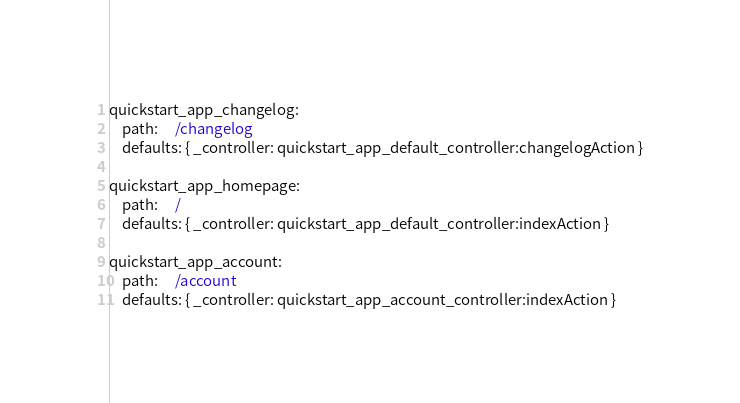<code> <loc_0><loc_0><loc_500><loc_500><_YAML_>quickstart_app_changelog:
    path:     /changelog
    defaults: { _controller: quickstart_app_default_controller:changelogAction }

quickstart_app_homepage:
    path:     /
    defaults: { _controller: quickstart_app_default_controller:indexAction }

quickstart_app_account:
    path:     /account
    defaults: { _controller: quickstart_app_account_controller:indexAction }
</code> 